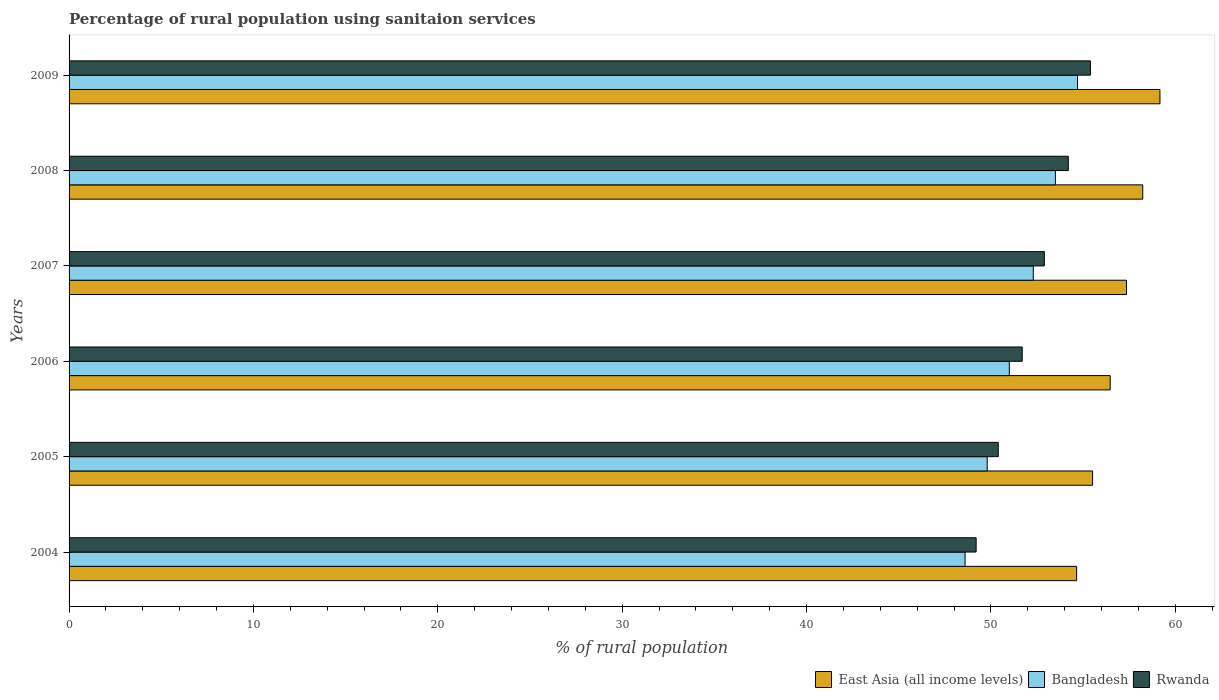How many bars are there on the 2nd tick from the top?
Your answer should be very brief. 3. In how many cases, is the number of bars for a given year not equal to the number of legend labels?
Your answer should be very brief. 0. What is the percentage of rural population using sanitaion services in Rwanda in 2006?
Make the answer very short. 51.7. Across all years, what is the maximum percentage of rural population using sanitaion services in Rwanda?
Provide a short and direct response. 55.4. Across all years, what is the minimum percentage of rural population using sanitaion services in Bangladesh?
Your answer should be compact. 48.6. In which year was the percentage of rural population using sanitaion services in Bangladesh maximum?
Make the answer very short. 2009. In which year was the percentage of rural population using sanitaion services in Rwanda minimum?
Your answer should be compact. 2004. What is the total percentage of rural population using sanitaion services in Rwanda in the graph?
Your answer should be very brief. 313.8. What is the difference between the percentage of rural population using sanitaion services in Bangladesh in 2005 and the percentage of rural population using sanitaion services in Rwanda in 2009?
Offer a very short reply. -5.6. What is the average percentage of rural population using sanitaion services in Bangladesh per year?
Your answer should be very brief. 51.65. In the year 2004, what is the difference between the percentage of rural population using sanitaion services in Bangladesh and percentage of rural population using sanitaion services in East Asia (all income levels)?
Give a very brief answer. -6.05. What is the ratio of the percentage of rural population using sanitaion services in Bangladesh in 2006 to that in 2009?
Make the answer very short. 0.93. Is the percentage of rural population using sanitaion services in Rwanda in 2007 less than that in 2008?
Ensure brevity in your answer.  Yes. Is the difference between the percentage of rural population using sanitaion services in Bangladesh in 2008 and 2009 greater than the difference between the percentage of rural population using sanitaion services in East Asia (all income levels) in 2008 and 2009?
Provide a succinct answer. No. What is the difference between the highest and the second highest percentage of rural population using sanitaion services in East Asia (all income levels)?
Give a very brief answer. 0.93. What is the difference between the highest and the lowest percentage of rural population using sanitaion services in East Asia (all income levels)?
Provide a short and direct response. 4.52. In how many years, is the percentage of rural population using sanitaion services in East Asia (all income levels) greater than the average percentage of rural population using sanitaion services in East Asia (all income levels) taken over all years?
Provide a succinct answer. 3. Is the sum of the percentage of rural population using sanitaion services in Bangladesh in 2008 and 2009 greater than the maximum percentage of rural population using sanitaion services in East Asia (all income levels) across all years?
Provide a short and direct response. Yes. What does the 2nd bar from the top in 2006 represents?
Provide a succinct answer. Bangladesh. What does the 2nd bar from the bottom in 2006 represents?
Your answer should be compact. Bangladesh. What is the difference between two consecutive major ticks on the X-axis?
Your answer should be compact. 10. Are the values on the major ticks of X-axis written in scientific E-notation?
Your answer should be compact. No. Does the graph contain any zero values?
Your answer should be very brief. No. Where does the legend appear in the graph?
Ensure brevity in your answer.  Bottom right. What is the title of the graph?
Provide a short and direct response. Percentage of rural population using sanitaion services. What is the label or title of the X-axis?
Make the answer very short. % of rural population. What is the label or title of the Y-axis?
Keep it short and to the point. Years. What is the % of rural population of East Asia (all income levels) in 2004?
Provide a short and direct response. 54.65. What is the % of rural population of Bangladesh in 2004?
Provide a succinct answer. 48.6. What is the % of rural population in Rwanda in 2004?
Offer a terse response. 49.2. What is the % of rural population in East Asia (all income levels) in 2005?
Your response must be concise. 55.52. What is the % of rural population of Bangladesh in 2005?
Your answer should be compact. 49.8. What is the % of rural population of Rwanda in 2005?
Keep it short and to the point. 50.4. What is the % of rural population of East Asia (all income levels) in 2006?
Give a very brief answer. 56.47. What is the % of rural population of Bangladesh in 2006?
Provide a short and direct response. 51. What is the % of rural population of Rwanda in 2006?
Provide a succinct answer. 51.7. What is the % of rural population in East Asia (all income levels) in 2007?
Make the answer very short. 57.36. What is the % of rural population of Bangladesh in 2007?
Give a very brief answer. 52.3. What is the % of rural population of Rwanda in 2007?
Your answer should be very brief. 52.9. What is the % of rural population in East Asia (all income levels) in 2008?
Give a very brief answer. 58.24. What is the % of rural population in Bangladesh in 2008?
Make the answer very short. 53.5. What is the % of rural population in Rwanda in 2008?
Your response must be concise. 54.2. What is the % of rural population of East Asia (all income levels) in 2009?
Your response must be concise. 59.17. What is the % of rural population in Bangladesh in 2009?
Give a very brief answer. 54.7. What is the % of rural population in Rwanda in 2009?
Keep it short and to the point. 55.4. Across all years, what is the maximum % of rural population in East Asia (all income levels)?
Your response must be concise. 59.17. Across all years, what is the maximum % of rural population in Bangladesh?
Your response must be concise. 54.7. Across all years, what is the maximum % of rural population of Rwanda?
Give a very brief answer. 55.4. Across all years, what is the minimum % of rural population of East Asia (all income levels)?
Give a very brief answer. 54.65. Across all years, what is the minimum % of rural population in Bangladesh?
Offer a terse response. 48.6. Across all years, what is the minimum % of rural population of Rwanda?
Provide a succinct answer. 49.2. What is the total % of rural population of East Asia (all income levels) in the graph?
Your response must be concise. 341.4. What is the total % of rural population of Bangladesh in the graph?
Make the answer very short. 309.9. What is the total % of rural population of Rwanda in the graph?
Your answer should be very brief. 313.8. What is the difference between the % of rural population of East Asia (all income levels) in 2004 and that in 2005?
Your answer should be compact. -0.86. What is the difference between the % of rural population of East Asia (all income levels) in 2004 and that in 2006?
Provide a succinct answer. -1.82. What is the difference between the % of rural population of Rwanda in 2004 and that in 2006?
Give a very brief answer. -2.5. What is the difference between the % of rural population in East Asia (all income levels) in 2004 and that in 2007?
Offer a very short reply. -2.7. What is the difference between the % of rural population in Bangladesh in 2004 and that in 2007?
Make the answer very short. -3.7. What is the difference between the % of rural population in East Asia (all income levels) in 2004 and that in 2008?
Make the answer very short. -3.58. What is the difference between the % of rural population of East Asia (all income levels) in 2004 and that in 2009?
Your answer should be compact. -4.52. What is the difference between the % of rural population in Bangladesh in 2004 and that in 2009?
Offer a terse response. -6.1. What is the difference between the % of rural population in Rwanda in 2004 and that in 2009?
Offer a terse response. -6.2. What is the difference between the % of rural population in East Asia (all income levels) in 2005 and that in 2006?
Provide a succinct answer. -0.96. What is the difference between the % of rural population of East Asia (all income levels) in 2005 and that in 2007?
Offer a terse response. -1.84. What is the difference between the % of rural population in Bangladesh in 2005 and that in 2007?
Keep it short and to the point. -2.5. What is the difference between the % of rural population of Rwanda in 2005 and that in 2007?
Your answer should be compact. -2.5. What is the difference between the % of rural population in East Asia (all income levels) in 2005 and that in 2008?
Ensure brevity in your answer.  -2.72. What is the difference between the % of rural population of East Asia (all income levels) in 2005 and that in 2009?
Provide a short and direct response. -3.65. What is the difference between the % of rural population in East Asia (all income levels) in 2006 and that in 2007?
Provide a short and direct response. -0.89. What is the difference between the % of rural population in Rwanda in 2006 and that in 2007?
Your answer should be very brief. -1.2. What is the difference between the % of rural population in East Asia (all income levels) in 2006 and that in 2008?
Your answer should be very brief. -1.77. What is the difference between the % of rural population of Rwanda in 2006 and that in 2008?
Keep it short and to the point. -2.5. What is the difference between the % of rural population in East Asia (all income levels) in 2006 and that in 2009?
Your response must be concise. -2.7. What is the difference between the % of rural population of Bangladesh in 2006 and that in 2009?
Offer a terse response. -3.7. What is the difference between the % of rural population of Rwanda in 2006 and that in 2009?
Provide a short and direct response. -3.7. What is the difference between the % of rural population of East Asia (all income levels) in 2007 and that in 2008?
Give a very brief answer. -0.88. What is the difference between the % of rural population in East Asia (all income levels) in 2007 and that in 2009?
Ensure brevity in your answer.  -1.81. What is the difference between the % of rural population of Bangladesh in 2007 and that in 2009?
Offer a terse response. -2.4. What is the difference between the % of rural population in Rwanda in 2007 and that in 2009?
Keep it short and to the point. -2.5. What is the difference between the % of rural population of East Asia (all income levels) in 2008 and that in 2009?
Ensure brevity in your answer.  -0.93. What is the difference between the % of rural population in Bangladesh in 2008 and that in 2009?
Offer a very short reply. -1.2. What is the difference between the % of rural population of Rwanda in 2008 and that in 2009?
Your answer should be compact. -1.2. What is the difference between the % of rural population in East Asia (all income levels) in 2004 and the % of rural population in Bangladesh in 2005?
Your response must be concise. 4.85. What is the difference between the % of rural population of East Asia (all income levels) in 2004 and the % of rural population of Rwanda in 2005?
Offer a very short reply. 4.25. What is the difference between the % of rural population in Bangladesh in 2004 and the % of rural population in Rwanda in 2005?
Provide a succinct answer. -1.8. What is the difference between the % of rural population of East Asia (all income levels) in 2004 and the % of rural population of Bangladesh in 2006?
Ensure brevity in your answer.  3.65. What is the difference between the % of rural population in East Asia (all income levels) in 2004 and the % of rural population in Rwanda in 2006?
Keep it short and to the point. 2.95. What is the difference between the % of rural population in East Asia (all income levels) in 2004 and the % of rural population in Bangladesh in 2007?
Offer a very short reply. 2.35. What is the difference between the % of rural population in East Asia (all income levels) in 2004 and the % of rural population in Rwanda in 2007?
Ensure brevity in your answer.  1.75. What is the difference between the % of rural population in East Asia (all income levels) in 2004 and the % of rural population in Bangladesh in 2008?
Provide a short and direct response. 1.15. What is the difference between the % of rural population in East Asia (all income levels) in 2004 and the % of rural population in Rwanda in 2008?
Offer a terse response. 0.45. What is the difference between the % of rural population of East Asia (all income levels) in 2004 and the % of rural population of Bangladesh in 2009?
Offer a terse response. -0.05. What is the difference between the % of rural population of East Asia (all income levels) in 2004 and the % of rural population of Rwanda in 2009?
Give a very brief answer. -0.75. What is the difference between the % of rural population of East Asia (all income levels) in 2005 and the % of rural population of Bangladesh in 2006?
Offer a very short reply. 4.52. What is the difference between the % of rural population of East Asia (all income levels) in 2005 and the % of rural population of Rwanda in 2006?
Your answer should be compact. 3.82. What is the difference between the % of rural population of Bangladesh in 2005 and the % of rural population of Rwanda in 2006?
Make the answer very short. -1.9. What is the difference between the % of rural population of East Asia (all income levels) in 2005 and the % of rural population of Bangladesh in 2007?
Offer a very short reply. 3.22. What is the difference between the % of rural population of East Asia (all income levels) in 2005 and the % of rural population of Rwanda in 2007?
Provide a succinct answer. 2.62. What is the difference between the % of rural population of East Asia (all income levels) in 2005 and the % of rural population of Bangladesh in 2008?
Offer a very short reply. 2.02. What is the difference between the % of rural population in East Asia (all income levels) in 2005 and the % of rural population in Rwanda in 2008?
Keep it short and to the point. 1.32. What is the difference between the % of rural population of East Asia (all income levels) in 2005 and the % of rural population of Bangladesh in 2009?
Ensure brevity in your answer.  0.82. What is the difference between the % of rural population in East Asia (all income levels) in 2005 and the % of rural population in Rwanda in 2009?
Offer a very short reply. 0.12. What is the difference between the % of rural population in East Asia (all income levels) in 2006 and the % of rural population in Bangladesh in 2007?
Make the answer very short. 4.17. What is the difference between the % of rural population of East Asia (all income levels) in 2006 and the % of rural population of Rwanda in 2007?
Provide a succinct answer. 3.57. What is the difference between the % of rural population in East Asia (all income levels) in 2006 and the % of rural population in Bangladesh in 2008?
Make the answer very short. 2.97. What is the difference between the % of rural population in East Asia (all income levels) in 2006 and the % of rural population in Rwanda in 2008?
Keep it short and to the point. 2.27. What is the difference between the % of rural population of East Asia (all income levels) in 2006 and the % of rural population of Bangladesh in 2009?
Your answer should be very brief. 1.77. What is the difference between the % of rural population in East Asia (all income levels) in 2006 and the % of rural population in Rwanda in 2009?
Ensure brevity in your answer.  1.07. What is the difference between the % of rural population in East Asia (all income levels) in 2007 and the % of rural population in Bangladesh in 2008?
Provide a short and direct response. 3.86. What is the difference between the % of rural population of East Asia (all income levels) in 2007 and the % of rural population of Rwanda in 2008?
Provide a short and direct response. 3.16. What is the difference between the % of rural population of East Asia (all income levels) in 2007 and the % of rural population of Bangladesh in 2009?
Your answer should be compact. 2.66. What is the difference between the % of rural population in East Asia (all income levels) in 2007 and the % of rural population in Rwanda in 2009?
Give a very brief answer. 1.96. What is the difference between the % of rural population in East Asia (all income levels) in 2008 and the % of rural population in Bangladesh in 2009?
Provide a short and direct response. 3.54. What is the difference between the % of rural population of East Asia (all income levels) in 2008 and the % of rural population of Rwanda in 2009?
Keep it short and to the point. 2.84. What is the average % of rural population of East Asia (all income levels) per year?
Your answer should be very brief. 56.9. What is the average % of rural population of Bangladesh per year?
Provide a short and direct response. 51.65. What is the average % of rural population of Rwanda per year?
Keep it short and to the point. 52.3. In the year 2004, what is the difference between the % of rural population of East Asia (all income levels) and % of rural population of Bangladesh?
Provide a short and direct response. 6.05. In the year 2004, what is the difference between the % of rural population of East Asia (all income levels) and % of rural population of Rwanda?
Your answer should be very brief. 5.45. In the year 2004, what is the difference between the % of rural population of Bangladesh and % of rural population of Rwanda?
Offer a very short reply. -0.6. In the year 2005, what is the difference between the % of rural population of East Asia (all income levels) and % of rural population of Bangladesh?
Your answer should be compact. 5.72. In the year 2005, what is the difference between the % of rural population of East Asia (all income levels) and % of rural population of Rwanda?
Provide a succinct answer. 5.12. In the year 2005, what is the difference between the % of rural population of Bangladesh and % of rural population of Rwanda?
Your answer should be very brief. -0.6. In the year 2006, what is the difference between the % of rural population in East Asia (all income levels) and % of rural population in Bangladesh?
Give a very brief answer. 5.47. In the year 2006, what is the difference between the % of rural population in East Asia (all income levels) and % of rural population in Rwanda?
Your response must be concise. 4.77. In the year 2006, what is the difference between the % of rural population of Bangladesh and % of rural population of Rwanda?
Offer a very short reply. -0.7. In the year 2007, what is the difference between the % of rural population of East Asia (all income levels) and % of rural population of Bangladesh?
Your response must be concise. 5.06. In the year 2007, what is the difference between the % of rural population of East Asia (all income levels) and % of rural population of Rwanda?
Your answer should be compact. 4.46. In the year 2008, what is the difference between the % of rural population in East Asia (all income levels) and % of rural population in Bangladesh?
Make the answer very short. 4.74. In the year 2008, what is the difference between the % of rural population in East Asia (all income levels) and % of rural population in Rwanda?
Keep it short and to the point. 4.04. In the year 2009, what is the difference between the % of rural population in East Asia (all income levels) and % of rural population in Bangladesh?
Make the answer very short. 4.47. In the year 2009, what is the difference between the % of rural population of East Asia (all income levels) and % of rural population of Rwanda?
Your answer should be very brief. 3.77. What is the ratio of the % of rural population in East Asia (all income levels) in 2004 to that in 2005?
Make the answer very short. 0.98. What is the ratio of the % of rural population of Bangladesh in 2004 to that in 2005?
Make the answer very short. 0.98. What is the ratio of the % of rural population in Rwanda in 2004 to that in 2005?
Offer a terse response. 0.98. What is the ratio of the % of rural population in East Asia (all income levels) in 2004 to that in 2006?
Keep it short and to the point. 0.97. What is the ratio of the % of rural population of Bangladesh in 2004 to that in 2006?
Keep it short and to the point. 0.95. What is the ratio of the % of rural population in Rwanda in 2004 to that in 2006?
Your answer should be very brief. 0.95. What is the ratio of the % of rural population in East Asia (all income levels) in 2004 to that in 2007?
Provide a short and direct response. 0.95. What is the ratio of the % of rural population of Bangladesh in 2004 to that in 2007?
Ensure brevity in your answer.  0.93. What is the ratio of the % of rural population in Rwanda in 2004 to that in 2007?
Offer a very short reply. 0.93. What is the ratio of the % of rural population in East Asia (all income levels) in 2004 to that in 2008?
Your answer should be very brief. 0.94. What is the ratio of the % of rural population of Bangladesh in 2004 to that in 2008?
Make the answer very short. 0.91. What is the ratio of the % of rural population in Rwanda in 2004 to that in 2008?
Your answer should be very brief. 0.91. What is the ratio of the % of rural population of East Asia (all income levels) in 2004 to that in 2009?
Offer a terse response. 0.92. What is the ratio of the % of rural population in Bangladesh in 2004 to that in 2009?
Offer a very short reply. 0.89. What is the ratio of the % of rural population of Rwanda in 2004 to that in 2009?
Keep it short and to the point. 0.89. What is the ratio of the % of rural population of East Asia (all income levels) in 2005 to that in 2006?
Offer a terse response. 0.98. What is the ratio of the % of rural population of Bangladesh in 2005 to that in 2006?
Give a very brief answer. 0.98. What is the ratio of the % of rural population in Rwanda in 2005 to that in 2006?
Your response must be concise. 0.97. What is the ratio of the % of rural population in East Asia (all income levels) in 2005 to that in 2007?
Provide a short and direct response. 0.97. What is the ratio of the % of rural population of Bangladesh in 2005 to that in 2007?
Your answer should be very brief. 0.95. What is the ratio of the % of rural population in Rwanda in 2005 to that in 2007?
Provide a short and direct response. 0.95. What is the ratio of the % of rural population in East Asia (all income levels) in 2005 to that in 2008?
Your answer should be compact. 0.95. What is the ratio of the % of rural population of Bangladesh in 2005 to that in 2008?
Provide a succinct answer. 0.93. What is the ratio of the % of rural population in Rwanda in 2005 to that in 2008?
Make the answer very short. 0.93. What is the ratio of the % of rural population of East Asia (all income levels) in 2005 to that in 2009?
Your answer should be very brief. 0.94. What is the ratio of the % of rural population of Bangladesh in 2005 to that in 2009?
Your response must be concise. 0.91. What is the ratio of the % of rural population in Rwanda in 2005 to that in 2009?
Make the answer very short. 0.91. What is the ratio of the % of rural population in East Asia (all income levels) in 2006 to that in 2007?
Offer a terse response. 0.98. What is the ratio of the % of rural population of Bangladesh in 2006 to that in 2007?
Give a very brief answer. 0.98. What is the ratio of the % of rural population of Rwanda in 2006 to that in 2007?
Keep it short and to the point. 0.98. What is the ratio of the % of rural population in East Asia (all income levels) in 2006 to that in 2008?
Your answer should be very brief. 0.97. What is the ratio of the % of rural population in Bangladesh in 2006 to that in 2008?
Keep it short and to the point. 0.95. What is the ratio of the % of rural population of Rwanda in 2006 to that in 2008?
Your answer should be very brief. 0.95. What is the ratio of the % of rural population of East Asia (all income levels) in 2006 to that in 2009?
Your answer should be compact. 0.95. What is the ratio of the % of rural population in Bangladesh in 2006 to that in 2009?
Offer a terse response. 0.93. What is the ratio of the % of rural population of Rwanda in 2006 to that in 2009?
Offer a terse response. 0.93. What is the ratio of the % of rural population in East Asia (all income levels) in 2007 to that in 2008?
Offer a very short reply. 0.98. What is the ratio of the % of rural population of Bangladesh in 2007 to that in 2008?
Offer a very short reply. 0.98. What is the ratio of the % of rural population in East Asia (all income levels) in 2007 to that in 2009?
Provide a short and direct response. 0.97. What is the ratio of the % of rural population of Bangladesh in 2007 to that in 2009?
Offer a terse response. 0.96. What is the ratio of the % of rural population of Rwanda in 2007 to that in 2009?
Provide a succinct answer. 0.95. What is the ratio of the % of rural population in East Asia (all income levels) in 2008 to that in 2009?
Provide a succinct answer. 0.98. What is the ratio of the % of rural population of Bangladesh in 2008 to that in 2009?
Provide a short and direct response. 0.98. What is the ratio of the % of rural population of Rwanda in 2008 to that in 2009?
Keep it short and to the point. 0.98. What is the difference between the highest and the second highest % of rural population of East Asia (all income levels)?
Your answer should be compact. 0.93. What is the difference between the highest and the lowest % of rural population of East Asia (all income levels)?
Make the answer very short. 4.52. What is the difference between the highest and the lowest % of rural population in Bangladesh?
Ensure brevity in your answer.  6.1. 